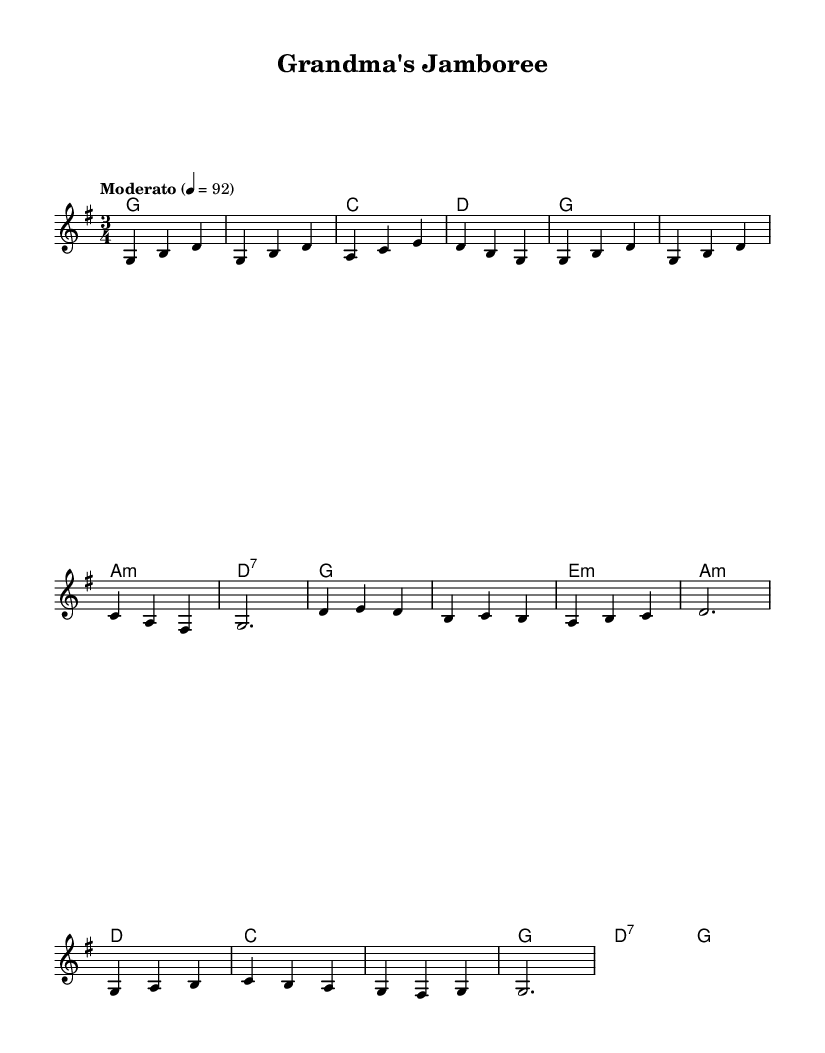What is the key signature of this music? The key signature is G major, which contains one sharp (F#). It can be determined by looking at the beginning of the sheet music where the key signature is indicated.
Answer: G major What is the time signature of this music? The time signature is 3/4, as indicated at the beginning of the score. This means there are three beats in each measure, with a quarter note receiving one beat.
Answer: 3/4 What is the tempo marking? The tempo marking is "Moderato", indicating a moderate speed for the piece. This is typically specified at the beginning of the score, often accompanied by a metronome mark which in this case is set to 92 beats per minute.
Answer: Moderato How many measures does the melody have? The melody contains 8 measures. This can be counted by looking at the system of notation and observing the grouping of notes and rests in the staff.
Answer: 8 Which chord follows the G major chord in the second measure? The chord following G major in the second measure is C major. One can see this by identifying the chord symbols above the staff, where the first chord in this measure is G and the second is C.
Answer: C major What is the ending note of the melody? The ending note of the melody is G. This is found at the last note of the melody line, which can be located at the end of the last measure.
Answer: G What is the predominant mood expressed in this folk tune? The predominant mood expressed in this folk tune is nostalgic. This can be inferred from the melodic content and the overall simplicity and charm of the tune that evokes images of countryside living.
Answer: Nostalgic 